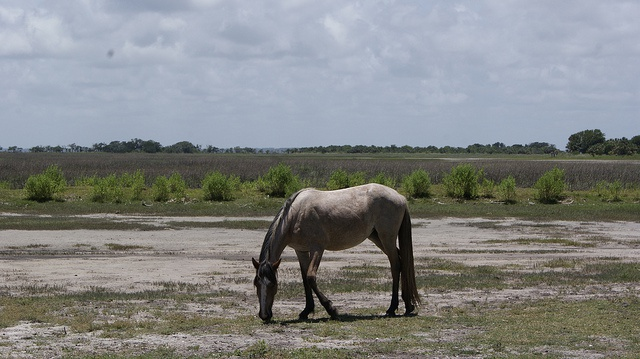Describe the objects in this image and their specific colors. I can see a horse in darkgray, black, and gray tones in this image. 